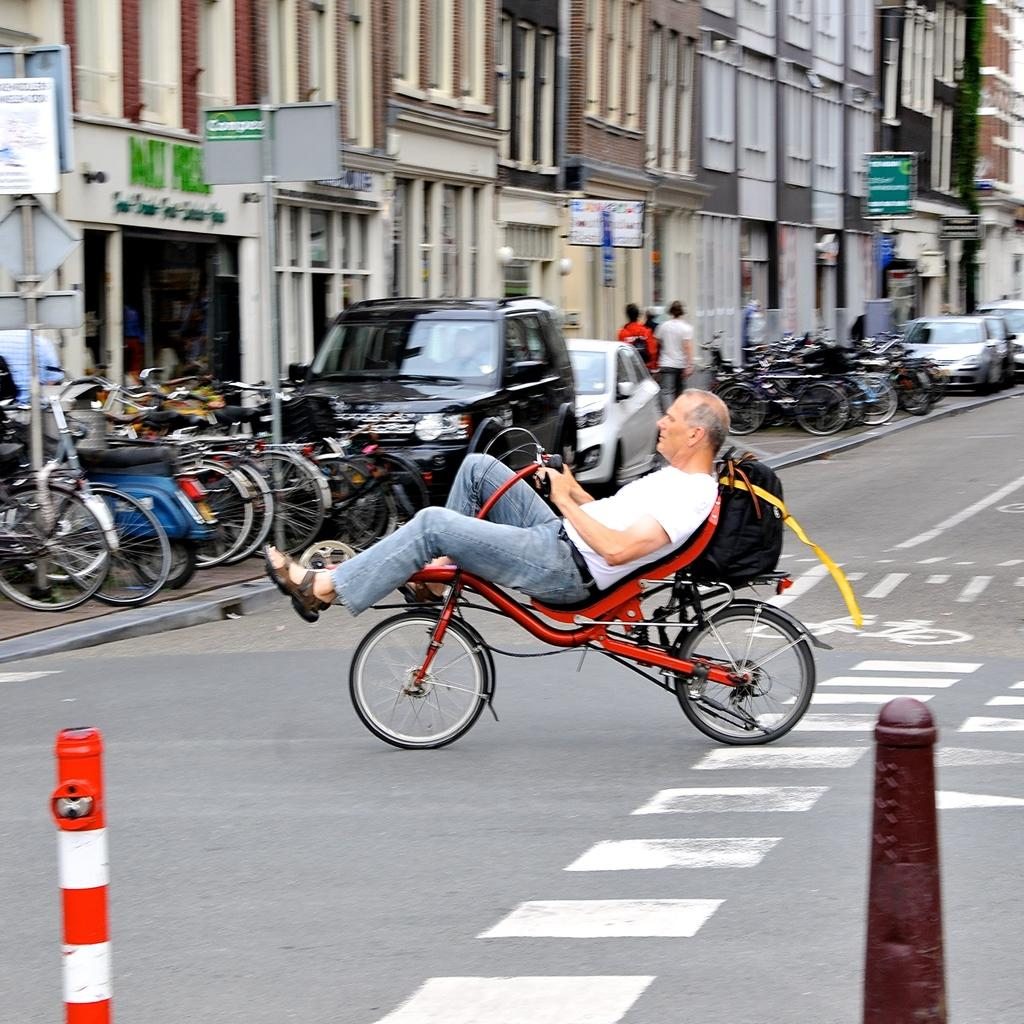Who is present in the image? There is a man in the image. What is the man doing in the image? The man is with his cycle in the image. What can be seen in the background of the image? There are other cycles, vehicles, and buildings in the background of the image. What type of fruit is hanging from the man's cycle in the image? There is no fruit present in the image, and it is not hanging from the man's cycle. 